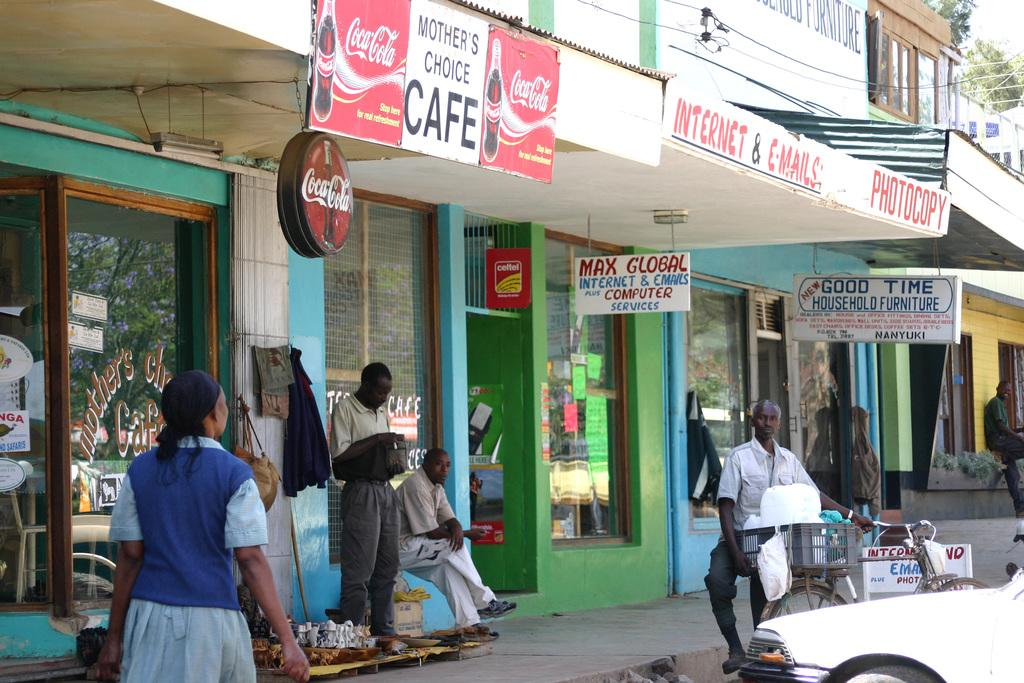Provide a one-sentence caption for the provided image. The Mother's Choice Cafe has Coca-Cola ads on it. 